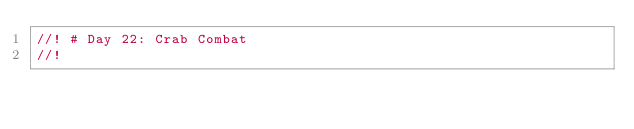<code> <loc_0><loc_0><loc_500><loc_500><_Rust_>//! # Day 22: Crab Combat
//!</code> 